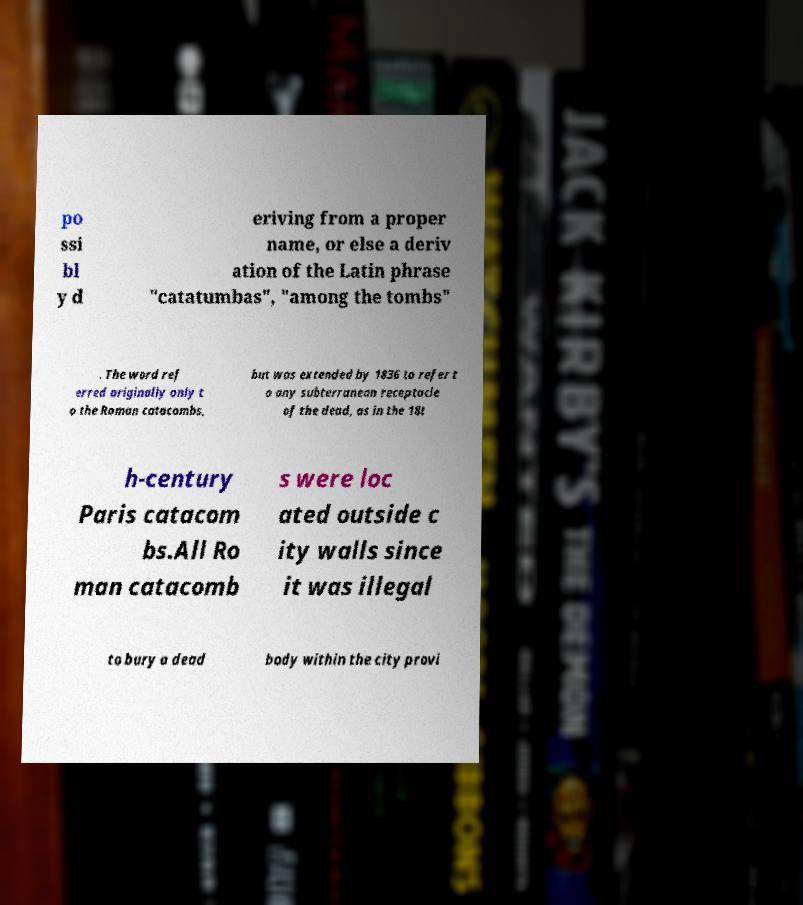Could you assist in decoding the text presented in this image and type it out clearly? po ssi bl y d eriving from a proper name, or else a deriv ation of the Latin phrase "catatumbas", "among the tombs" . The word ref erred originally only t o the Roman catacombs, but was extended by 1836 to refer t o any subterranean receptacle of the dead, as in the 18t h-century Paris catacom bs.All Ro man catacomb s were loc ated outside c ity walls since it was illegal to bury a dead body within the city provi 